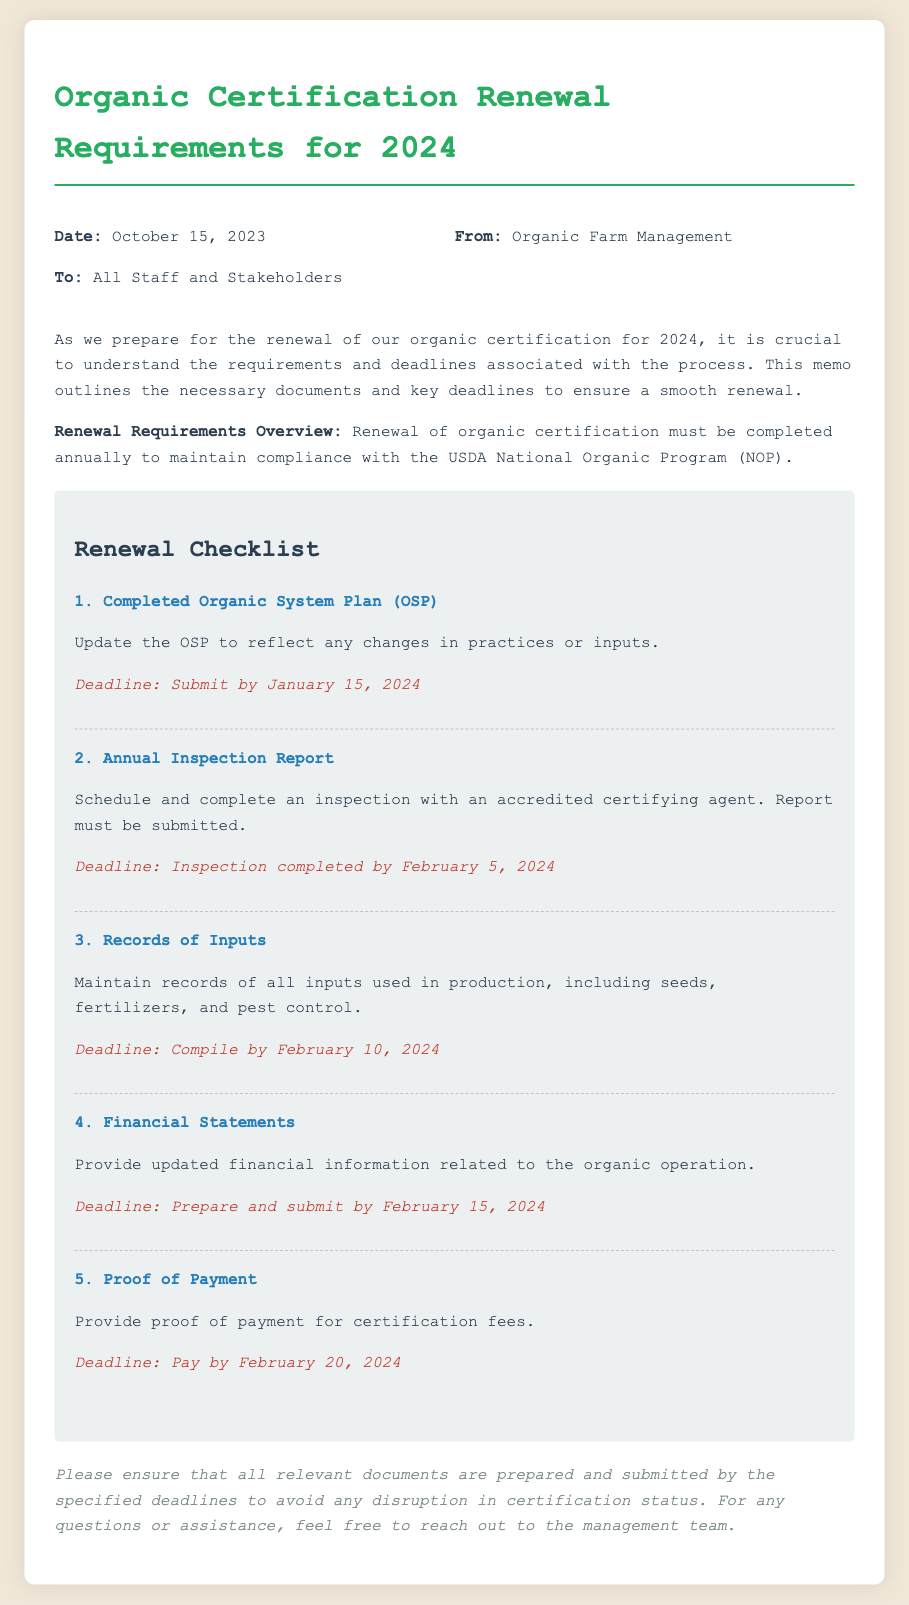What is the date of the memo? The date of the memo is explicitly stated at the beginning of the document: October 15, 2023.
Answer: October 15, 2023 Who is the memo addressed to? The memo is addressed to "All Staff and Stakeholders" as indicated in the header section.
Answer: All Staff and Stakeholders What is the first document required for renewal? The memo outlines a checklist, and the first document listed is the "Completed Organic System Plan (OSP)."
Answer: Completed Organic System Plan (OSP) What is the deadline for submitting the OSP? The deadline to submit the OSP is mentioned directly under the document requirement: January 15, 2024.
Answer: January 15, 2024 How many documents are listed in the renewal checklist? The memo provides a checklist of five specific documents required for organic certification renewal.
Answer: 5 What are records of inputs used for? The memo specifies that "records of inputs" are necessary to maintain records of all inputs used in production.
Answer: To maintain records of all inputs used in production What is the latest date to pay the certification fees? The deadline for paying the certification fees is explicitly stated in the checklist as February 20, 2024.
Answer: February 20, 2024 Why is it important to prepare and submit documents by the deadlines? The conclusion emphasizes the significance of timely submission to avoid disruption in certification status.
Answer: To avoid any disruption in certification status 